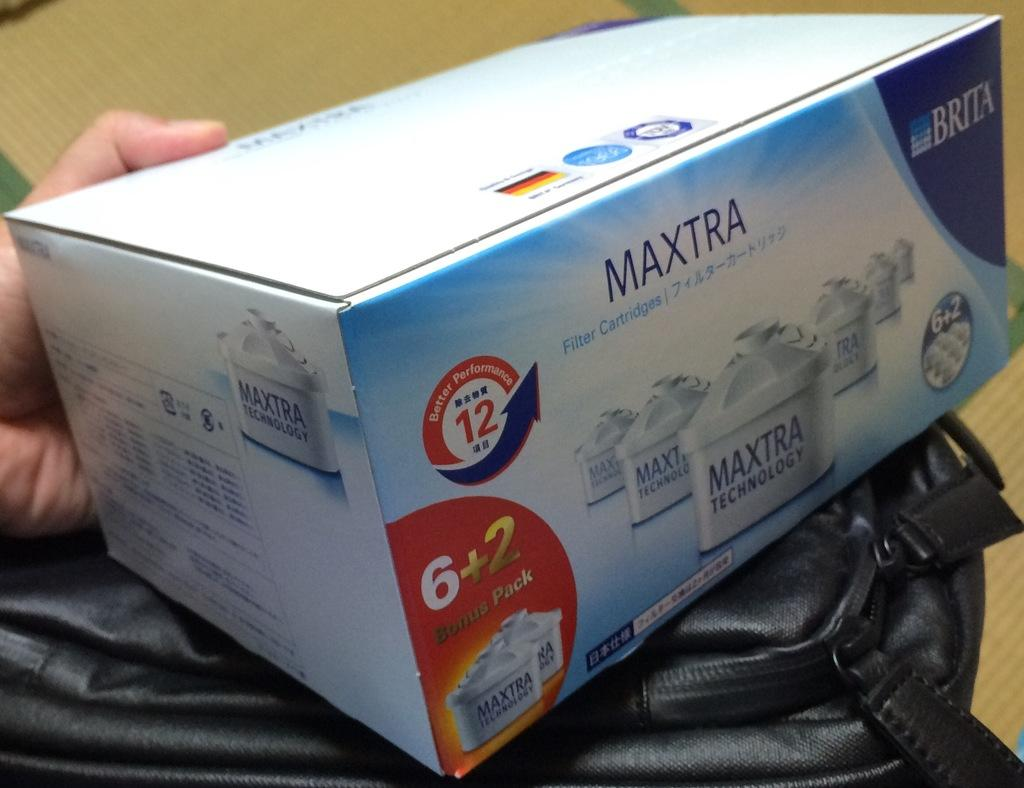Provide a one-sentence caption for the provided image. Maxtra Technology Filter Cartridges presented by Brita, contains a bonus pack of 6 and 2. 